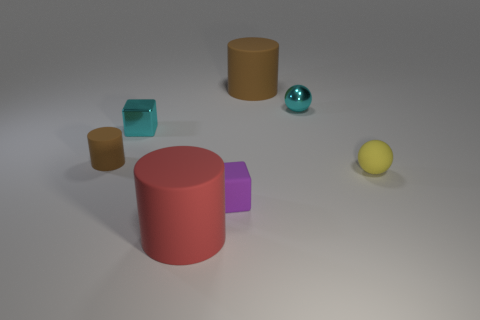Add 1 small yellow balls. How many objects exist? 8 Subtract all balls. How many objects are left? 5 Add 2 small gray cylinders. How many small gray cylinders exist? 2 Subtract 0 green balls. How many objects are left? 7 Subtract all small cyan cubes. Subtract all yellow spheres. How many objects are left? 5 Add 7 cyan metallic cubes. How many cyan metallic cubes are left? 8 